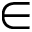<formula> <loc_0><loc_0><loc_500><loc_500>\in</formula> 